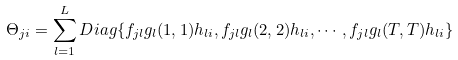Convert formula to latex. <formula><loc_0><loc_0><loc_500><loc_500>\Theta _ { j i } = \sum _ { l = 1 } ^ { L } D i a g \{ f _ { j l } { g _ { l } } ( 1 , 1 ) h _ { l i } , f _ { j l } g _ { l } ( 2 , 2 ) h _ { l i } , \cdots , f _ { j l } g _ { l } ( T , T ) h _ { l i } \}</formula> 